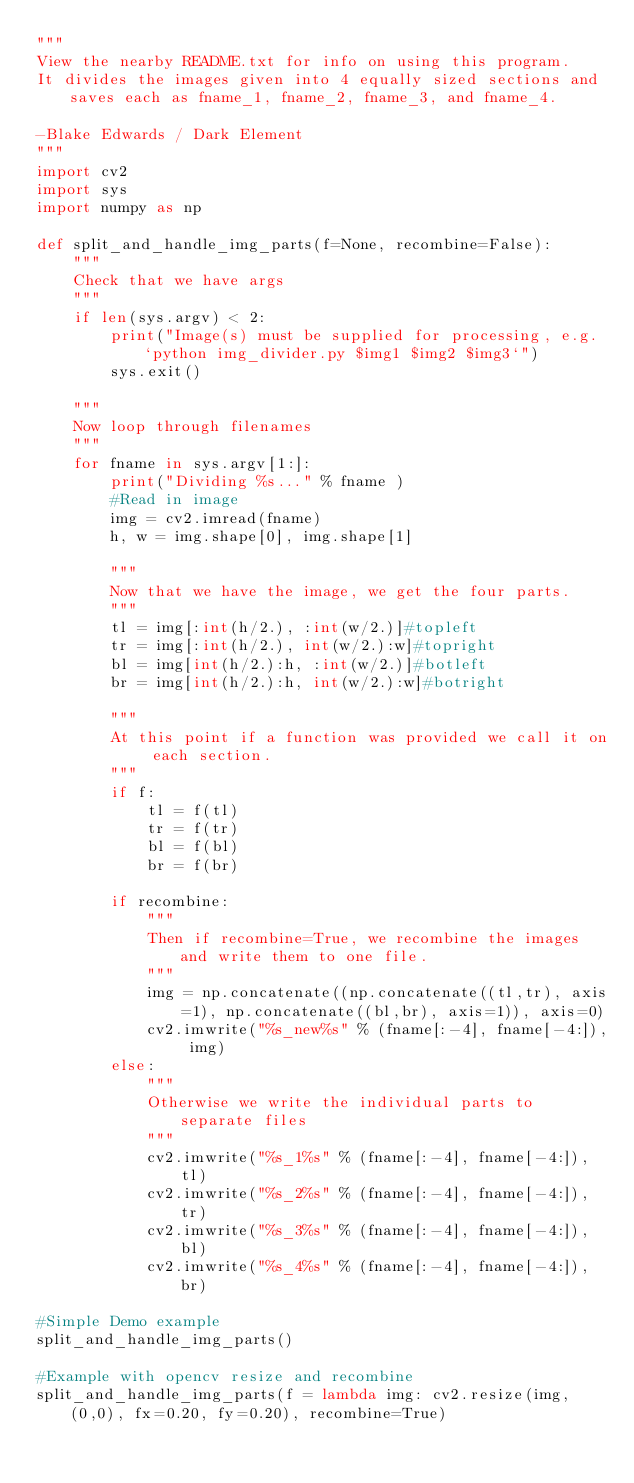Convert code to text. <code><loc_0><loc_0><loc_500><loc_500><_Python_>"""
View the nearby README.txt for info on using this program.
It divides the images given into 4 equally sized sections and saves each as fname_1, fname_2, fname_3, and fname_4.

-Blake Edwards / Dark Element
"""
import cv2
import sys
import numpy as np

def split_and_handle_img_parts(f=None, recombine=False):
    """
    Check that we have args
    """
    if len(sys.argv) < 2:
        print("Image(s) must be supplied for processing, e.g. `python img_divider.py $img1 $img2 $img3`")
        sys.exit()
        
    """
    Now loop through filenames
    """
    for fname in sys.argv[1:]:
        print("Dividing %s..." % fname )
        #Read in image
        img = cv2.imread(fname)
        h, w = img.shape[0], img.shape[1]

        """
        Now that we have the image, we get the four parts.
        """
        tl = img[:int(h/2.), :int(w/2.)]#topleft
        tr = img[:int(h/2.), int(w/2.):w]#topright
        bl = img[int(h/2.):h, :int(w/2.)]#botleft
        br = img[int(h/2.):h, int(w/2.):w]#botright

        """
        At this point if a function was provided we call it on each section.
        """
        if f:
            tl = f(tl)
            tr = f(tr)
            bl = f(bl)
            br = f(br)

        if recombine:
            """
            Then if recombine=True, we recombine the images and write them to one file.
            """
            img = np.concatenate((np.concatenate((tl,tr), axis=1), np.concatenate((bl,br), axis=1)), axis=0)
            cv2.imwrite("%s_new%s" % (fname[:-4], fname[-4:]), img)
        else:
            """
            Otherwise we write the individual parts to separate files
            """
            cv2.imwrite("%s_1%s" % (fname[:-4], fname[-4:]), tl)
            cv2.imwrite("%s_2%s" % (fname[:-4], fname[-4:]), tr)
            cv2.imwrite("%s_3%s" % (fname[:-4], fname[-4:]), bl)
            cv2.imwrite("%s_4%s" % (fname[:-4], fname[-4:]), br)

#Simple Demo example
split_and_handle_img_parts()

#Example with opencv resize and recombine
split_and_handle_img_parts(f = lambda img: cv2.resize(img, (0,0), fx=0.20, fy=0.20), recombine=True)

</code> 